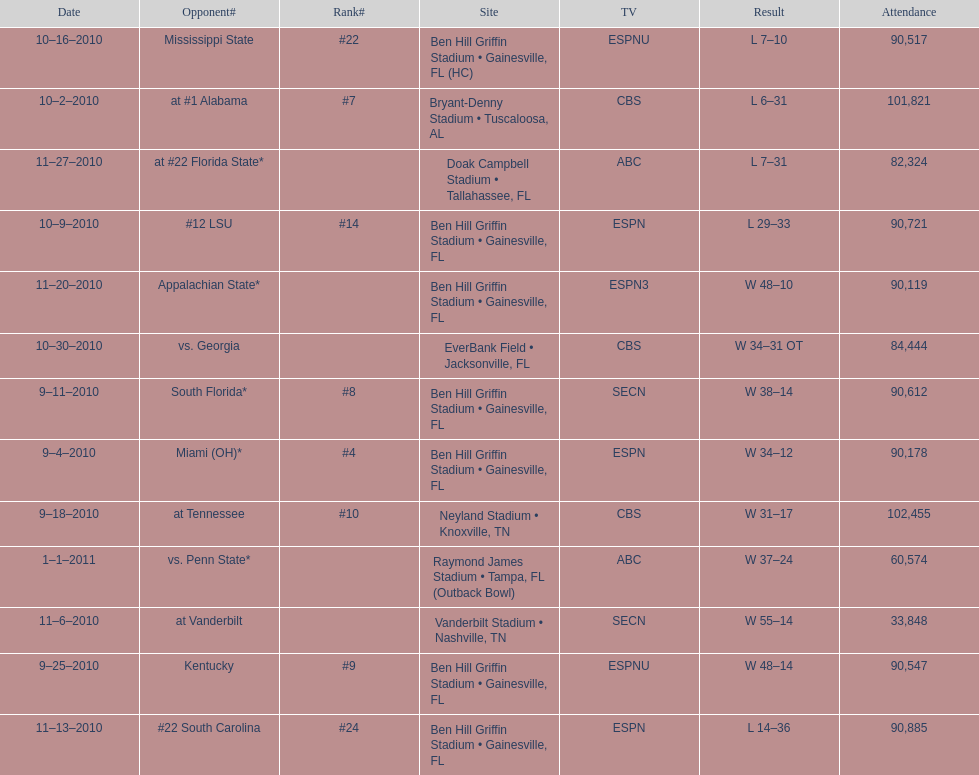How many consecutive weeks did the the gators win until the had their first lost in the 2010 season? 4. 